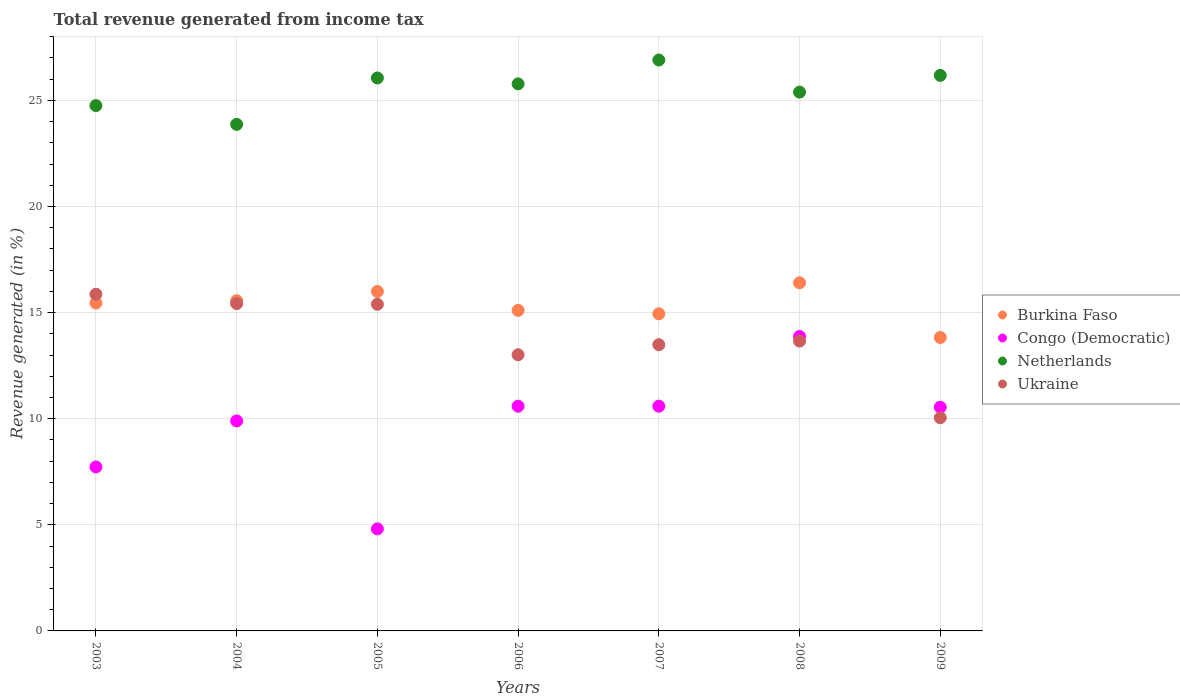How many different coloured dotlines are there?
Your answer should be compact. 4. What is the total revenue generated in Ukraine in 2004?
Give a very brief answer. 15.42. Across all years, what is the maximum total revenue generated in Burkina Faso?
Keep it short and to the point. 16.4. Across all years, what is the minimum total revenue generated in Netherlands?
Give a very brief answer. 23.87. In which year was the total revenue generated in Congo (Democratic) maximum?
Your answer should be compact. 2008. What is the total total revenue generated in Netherlands in the graph?
Keep it short and to the point. 178.93. What is the difference between the total revenue generated in Burkina Faso in 2004 and that in 2006?
Offer a terse response. 0.45. What is the difference between the total revenue generated in Burkina Faso in 2003 and the total revenue generated in Ukraine in 2009?
Provide a short and direct response. 5.4. What is the average total revenue generated in Ukraine per year?
Ensure brevity in your answer.  13.84. In the year 2004, what is the difference between the total revenue generated in Burkina Faso and total revenue generated in Congo (Democratic)?
Offer a very short reply. 5.66. In how many years, is the total revenue generated in Congo (Democratic) greater than 11 %?
Ensure brevity in your answer.  1. What is the ratio of the total revenue generated in Burkina Faso in 2003 to that in 2007?
Your response must be concise. 1.03. Is the total revenue generated in Congo (Democratic) in 2005 less than that in 2007?
Provide a short and direct response. Yes. What is the difference between the highest and the second highest total revenue generated in Netherlands?
Provide a succinct answer. 0.72. What is the difference between the highest and the lowest total revenue generated in Congo (Democratic)?
Provide a short and direct response. 9.07. In how many years, is the total revenue generated in Netherlands greater than the average total revenue generated in Netherlands taken over all years?
Give a very brief answer. 4. Is the sum of the total revenue generated in Netherlands in 2003 and 2009 greater than the maximum total revenue generated in Ukraine across all years?
Your answer should be compact. Yes. Is it the case that in every year, the sum of the total revenue generated in Congo (Democratic) and total revenue generated in Ukraine  is greater than the sum of total revenue generated in Netherlands and total revenue generated in Burkina Faso?
Your answer should be very brief. No. Is it the case that in every year, the sum of the total revenue generated in Ukraine and total revenue generated in Netherlands  is greater than the total revenue generated in Burkina Faso?
Ensure brevity in your answer.  Yes. Does the total revenue generated in Ukraine monotonically increase over the years?
Make the answer very short. No. Is the total revenue generated in Congo (Democratic) strictly greater than the total revenue generated in Ukraine over the years?
Your answer should be very brief. No. Does the graph contain any zero values?
Keep it short and to the point. No. What is the title of the graph?
Your response must be concise. Total revenue generated from income tax. Does "Rwanda" appear as one of the legend labels in the graph?
Offer a very short reply. No. What is the label or title of the X-axis?
Offer a terse response. Years. What is the label or title of the Y-axis?
Give a very brief answer. Revenue generated (in %). What is the Revenue generated (in %) in Burkina Faso in 2003?
Your answer should be compact. 15.45. What is the Revenue generated (in %) in Congo (Democratic) in 2003?
Your answer should be compact. 7.73. What is the Revenue generated (in %) in Netherlands in 2003?
Your answer should be very brief. 24.75. What is the Revenue generated (in %) in Ukraine in 2003?
Make the answer very short. 15.87. What is the Revenue generated (in %) of Burkina Faso in 2004?
Offer a terse response. 15.56. What is the Revenue generated (in %) of Congo (Democratic) in 2004?
Offer a very short reply. 9.9. What is the Revenue generated (in %) in Netherlands in 2004?
Provide a succinct answer. 23.87. What is the Revenue generated (in %) in Ukraine in 2004?
Offer a very short reply. 15.42. What is the Revenue generated (in %) in Burkina Faso in 2005?
Offer a terse response. 16. What is the Revenue generated (in %) in Congo (Democratic) in 2005?
Provide a short and direct response. 4.81. What is the Revenue generated (in %) in Netherlands in 2005?
Provide a short and direct response. 26.06. What is the Revenue generated (in %) in Ukraine in 2005?
Your response must be concise. 15.39. What is the Revenue generated (in %) in Burkina Faso in 2006?
Give a very brief answer. 15.11. What is the Revenue generated (in %) of Congo (Democratic) in 2006?
Your response must be concise. 10.59. What is the Revenue generated (in %) in Netherlands in 2006?
Ensure brevity in your answer.  25.78. What is the Revenue generated (in %) of Ukraine in 2006?
Your answer should be compact. 13.01. What is the Revenue generated (in %) in Burkina Faso in 2007?
Make the answer very short. 14.94. What is the Revenue generated (in %) of Congo (Democratic) in 2007?
Give a very brief answer. 10.59. What is the Revenue generated (in %) in Netherlands in 2007?
Your response must be concise. 26.9. What is the Revenue generated (in %) of Ukraine in 2007?
Your answer should be very brief. 13.49. What is the Revenue generated (in %) in Burkina Faso in 2008?
Ensure brevity in your answer.  16.4. What is the Revenue generated (in %) of Congo (Democratic) in 2008?
Offer a very short reply. 13.88. What is the Revenue generated (in %) of Netherlands in 2008?
Keep it short and to the point. 25.39. What is the Revenue generated (in %) of Ukraine in 2008?
Offer a terse response. 13.66. What is the Revenue generated (in %) in Burkina Faso in 2009?
Your answer should be very brief. 13.83. What is the Revenue generated (in %) of Congo (Democratic) in 2009?
Provide a succinct answer. 10.54. What is the Revenue generated (in %) of Netherlands in 2009?
Offer a terse response. 26.18. What is the Revenue generated (in %) of Ukraine in 2009?
Provide a short and direct response. 10.05. Across all years, what is the maximum Revenue generated (in %) of Burkina Faso?
Provide a short and direct response. 16.4. Across all years, what is the maximum Revenue generated (in %) in Congo (Democratic)?
Your answer should be compact. 13.88. Across all years, what is the maximum Revenue generated (in %) in Netherlands?
Ensure brevity in your answer.  26.9. Across all years, what is the maximum Revenue generated (in %) of Ukraine?
Offer a very short reply. 15.87. Across all years, what is the minimum Revenue generated (in %) in Burkina Faso?
Make the answer very short. 13.83. Across all years, what is the minimum Revenue generated (in %) in Congo (Democratic)?
Provide a succinct answer. 4.81. Across all years, what is the minimum Revenue generated (in %) of Netherlands?
Offer a terse response. 23.87. Across all years, what is the minimum Revenue generated (in %) in Ukraine?
Your answer should be very brief. 10.05. What is the total Revenue generated (in %) in Burkina Faso in the graph?
Provide a succinct answer. 107.28. What is the total Revenue generated (in %) in Congo (Democratic) in the graph?
Offer a terse response. 68.02. What is the total Revenue generated (in %) in Netherlands in the graph?
Give a very brief answer. 178.93. What is the total Revenue generated (in %) in Ukraine in the graph?
Provide a short and direct response. 96.89. What is the difference between the Revenue generated (in %) in Burkina Faso in 2003 and that in 2004?
Your response must be concise. -0.11. What is the difference between the Revenue generated (in %) in Congo (Democratic) in 2003 and that in 2004?
Your response must be concise. -2.17. What is the difference between the Revenue generated (in %) of Netherlands in 2003 and that in 2004?
Make the answer very short. 0.88. What is the difference between the Revenue generated (in %) of Ukraine in 2003 and that in 2004?
Make the answer very short. 0.44. What is the difference between the Revenue generated (in %) in Burkina Faso in 2003 and that in 2005?
Give a very brief answer. -0.55. What is the difference between the Revenue generated (in %) in Congo (Democratic) in 2003 and that in 2005?
Your answer should be very brief. 2.92. What is the difference between the Revenue generated (in %) of Netherlands in 2003 and that in 2005?
Ensure brevity in your answer.  -1.3. What is the difference between the Revenue generated (in %) in Ukraine in 2003 and that in 2005?
Provide a short and direct response. 0.47. What is the difference between the Revenue generated (in %) in Burkina Faso in 2003 and that in 2006?
Make the answer very short. 0.34. What is the difference between the Revenue generated (in %) of Congo (Democratic) in 2003 and that in 2006?
Your answer should be compact. -2.86. What is the difference between the Revenue generated (in %) in Netherlands in 2003 and that in 2006?
Keep it short and to the point. -1.02. What is the difference between the Revenue generated (in %) in Ukraine in 2003 and that in 2006?
Provide a succinct answer. 2.85. What is the difference between the Revenue generated (in %) of Burkina Faso in 2003 and that in 2007?
Keep it short and to the point. 0.51. What is the difference between the Revenue generated (in %) in Congo (Democratic) in 2003 and that in 2007?
Ensure brevity in your answer.  -2.86. What is the difference between the Revenue generated (in %) in Netherlands in 2003 and that in 2007?
Provide a short and direct response. -2.15. What is the difference between the Revenue generated (in %) in Ukraine in 2003 and that in 2007?
Provide a succinct answer. 2.38. What is the difference between the Revenue generated (in %) of Burkina Faso in 2003 and that in 2008?
Provide a succinct answer. -0.95. What is the difference between the Revenue generated (in %) in Congo (Democratic) in 2003 and that in 2008?
Your response must be concise. -6.15. What is the difference between the Revenue generated (in %) of Netherlands in 2003 and that in 2008?
Give a very brief answer. -0.63. What is the difference between the Revenue generated (in %) of Ukraine in 2003 and that in 2008?
Offer a very short reply. 2.21. What is the difference between the Revenue generated (in %) of Burkina Faso in 2003 and that in 2009?
Keep it short and to the point. 1.62. What is the difference between the Revenue generated (in %) in Congo (Democratic) in 2003 and that in 2009?
Your answer should be compact. -2.81. What is the difference between the Revenue generated (in %) of Netherlands in 2003 and that in 2009?
Your response must be concise. -1.42. What is the difference between the Revenue generated (in %) in Ukraine in 2003 and that in 2009?
Your answer should be compact. 5.82. What is the difference between the Revenue generated (in %) in Burkina Faso in 2004 and that in 2005?
Offer a very short reply. -0.44. What is the difference between the Revenue generated (in %) of Congo (Democratic) in 2004 and that in 2005?
Offer a very short reply. 5.09. What is the difference between the Revenue generated (in %) of Netherlands in 2004 and that in 2005?
Ensure brevity in your answer.  -2.19. What is the difference between the Revenue generated (in %) of Ukraine in 2004 and that in 2005?
Your answer should be very brief. 0.03. What is the difference between the Revenue generated (in %) in Burkina Faso in 2004 and that in 2006?
Make the answer very short. 0.45. What is the difference between the Revenue generated (in %) of Congo (Democratic) in 2004 and that in 2006?
Provide a short and direct response. -0.69. What is the difference between the Revenue generated (in %) of Netherlands in 2004 and that in 2006?
Offer a very short reply. -1.91. What is the difference between the Revenue generated (in %) of Ukraine in 2004 and that in 2006?
Your answer should be compact. 2.41. What is the difference between the Revenue generated (in %) of Burkina Faso in 2004 and that in 2007?
Keep it short and to the point. 0.62. What is the difference between the Revenue generated (in %) of Congo (Democratic) in 2004 and that in 2007?
Your answer should be very brief. -0.69. What is the difference between the Revenue generated (in %) of Netherlands in 2004 and that in 2007?
Your answer should be compact. -3.03. What is the difference between the Revenue generated (in %) in Ukraine in 2004 and that in 2007?
Offer a terse response. 1.94. What is the difference between the Revenue generated (in %) in Burkina Faso in 2004 and that in 2008?
Offer a very short reply. -0.85. What is the difference between the Revenue generated (in %) in Congo (Democratic) in 2004 and that in 2008?
Ensure brevity in your answer.  -3.98. What is the difference between the Revenue generated (in %) of Netherlands in 2004 and that in 2008?
Offer a very short reply. -1.52. What is the difference between the Revenue generated (in %) of Ukraine in 2004 and that in 2008?
Ensure brevity in your answer.  1.77. What is the difference between the Revenue generated (in %) in Burkina Faso in 2004 and that in 2009?
Your answer should be compact. 1.73. What is the difference between the Revenue generated (in %) in Congo (Democratic) in 2004 and that in 2009?
Offer a terse response. -0.64. What is the difference between the Revenue generated (in %) of Netherlands in 2004 and that in 2009?
Your response must be concise. -2.31. What is the difference between the Revenue generated (in %) in Ukraine in 2004 and that in 2009?
Provide a succinct answer. 5.38. What is the difference between the Revenue generated (in %) in Burkina Faso in 2005 and that in 2006?
Provide a short and direct response. 0.89. What is the difference between the Revenue generated (in %) of Congo (Democratic) in 2005 and that in 2006?
Your response must be concise. -5.78. What is the difference between the Revenue generated (in %) in Netherlands in 2005 and that in 2006?
Ensure brevity in your answer.  0.28. What is the difference between the Revenue generated (in %) of Ukraine in 2005 and that in 2006?
Offer a very short reply. 2.38. What is the difference between the Revenue generated (in %) in Burkina Faso in 2005 and that in 2007?
Your answer should be compact. 1.05. What is the difference between the Revenue generated (in %) of Congo (Democratic) in 2005 and that in 2007?
Offer a very short reply. -5.78. What is the difference between the Revenue generated (in %) in Netherlands in 2005 and that in 2007?
Your response must be concise. -0.85. What is the difference between the Revenue generated (in %) of Ukraine in 2005 and that in 2007?
Offer a very short reply. 1.9. What is the difference between the Revenue generated (in %) in Burkina Faso in 2005 and that in 2008?
Your answer should be compact. -0.41. What is the difference between the Revenue generated (in %) in Congo (Democratic) in 2005 and that in 2008?
Ensure brevity in your answer.  -9.07. What is the difference between the Revenue generated (in %) of Netherlands in 2005 and that in 2008?
Ensure brevity in your answer.  0.67. What is the difference between the Revenue generated (in %) in Ukraine in 2005 and that in 2008?
Keep it short and to the point. 1.73. What is the difference between the Revenue generated (in %) of Burkina Faso in 2005 and that in 2009?
Keep it short and to the point. 2.17. What is the difference between the Revenue generated (in %) of Congo (Democratic) in 2005 and that in 2009?
Your answer should be very brief. -5.73. What is the difference between the Revenue generated (in %) of Netherlands in 2005 and that in 2009?
Keep it short and to the point. -0.12. What is the difference between the Revenue generated (in %) of Ukraine in 2005 and that in 2009?
Make the answer very short. 5.35. What is the difference between the Revenue generated (in %) in Burkina Faso in 2006 and that in 2007?
Your response must be concise. 0.16. What is the difference between the Revenue generated (in %) in Congo (Democratic) in 2006 and that in 2007?
Your response must be concise. -0. What is the difference between the Revenue generated (in %) of Netherlands in 2006 and that in 2007?
Offer a very short reply. -1.12. What is the difference between the Revenue generated (in %) in Ukraine in 2006 and that in 2007?
Keep it short and to the point. -0.47. What is the difference between the Revenue generated (in %) of Burkina Faso in 2006 and that in 2008?
Your answer should be very brief. -1.3. What is the difference between the Revenue generated (in %) in Congo (Democratic) in 2006 and that in 2008?
Provide a short and direct response. -3.29. What is the difference between the Revenue generated (in %) of Netherlands in 2006 and that in 2008?
Provide a short and direct response. 0.39. What is the difference between the Revenue generated (in %) of Ukraine in 2006 and that in 2008?
Offer a very short reply. -0.64. What is the difference between the Revenue generated (in %) of Burkina Faso in 2006 and that in 2009?
Give a very brief answer. 1.28. What is the difference between the Revenue generated (in %) of Congo (Democratic) in 2006 and that in 2009?
Make the answer very short. 0.05. What is the difference between the Revenue generated (in %) of Ukraine in 2006 and that in 2009?
Ensure brevity in your answer.  2.97. What is the difference between the Revenue generated (in %) of Burkina Faso in 2007 and that in 2008?
Your answer should be compact. -1.46. What is the difference between the Revenue generated (in %) in Congo (Democratic) in 2007 and that in 2008?
Your answer should be compact. -3.28. What is the difference between the Revenue generated (in %) of Netherlands in 2007 and that in 2008?
Give a very brief answer. 1.51. What is the difference between the Revenue generated (in %) in Ukraine in 2007 and that in 2008?
Provide a short and direct response. -0.17. What is the difference between the Revenue generated (in %) in Burkina Faso in 2007 and that in 2009?
Offer a very short reply. 1.11. What is the difference between the Revenue generated (in %) of Congo (Democratic) in 2007 and that in 2009?
Keep it short and to the point. 0.05. What is the difference between the Revenue generated (in %) in Netherlands in 2007 and that in 2009?
Ensure brevity in your answer.  0.72. What is the difference between the Revenue generated (in %) in Ukraine in 2007 and that in 2009?
Offer a very short reply. 3.44. What is the difference between the Revenue generated (in %) of Burkina Faso in 2008 and that in 2009?
Make the answer very short. 2.58. What is the difference between the Revenue generated (in %) in Congo (Democratic) in 2008 and that in 2009?
Offer a terse response. 3.33. What is the difference between the Revenue generated (in %) in Netherlands in 2008 and that in 2009?
Your response must be concise. -0.79. What is the difference between the Revenue generated (in %) of Ukraine in 2008 and that in 2009?
Give a very brief answer. 3.61. What is the difference between the Revenue generated (in %) of Burkina Faso in 2003 and the Revenue generated (in %) of Congo (Democratic) in 2004?
Offer a very short reply. 5.55. What is the difference between the Revenue generated (in %) in Burkina Faso in 2003 and the Revenue generated (in %) in Netherlands in 2004?
Provide a short and direct response. -8.42. What is the difference between the Revenue generated (in %) of Burkina Faso in 2003 and the Revenue generated (in %) of Ukraine in 2004?
Provide a succinct answer. 0.02. What is the difference between the Revenue generated (in %) in Congo (Democratic) in 2003 and the Revenue generated (in %) in Netherlands in 2004?
Make the answer very short. -16.14. What is the difference between the Revenue generated (in %) of Congo (Democratic) in 2003 and the Revenue generated (in %) of Ukraine in 2004?
Your response must be concise. -7.7. What is the difference between the Revenue generated (in %) in Netherlands in 2003 and the Revenue generated (in %) in Ukraine in 2004?
Give a very brief answer. 9.33. What is the difference between the Revenue generated (in %) in Burkina Faso in 2003 and the Revenue generated (in %) in Congo (Democratic) in 2005?
Provide a succinct answer. 10.64. What is the difference between the Revenue generated (in %) in Burkina Faso in 2003 and the Revenue generated (in %) in Netherlands in 2005?
Offer a very short reply. -10.61. What is the difference between the Revenue generated (in %) of Burkina Faso in 2003 and the Revenue generated (in %) of Ukraine in 2005?
Make the answer very short. 0.06. What is the difference between the Revenue generated (in %) of Congo (Democratic) in 2003 and the Revenue generated (in %) of Netherlands in 2005?
Provide a succinct answer. -18.33. What is the difference between the Revenue generated (in %) in Congo (Democratic) in 2003 and the Revenue generated (in %) in Ukraine in 2005?
Give a very brief answer. -7.67. What is the difference between the Revenue generated (in %) of Netherlands in 2003 and the Revenue generated (in %) of Ukraine in 2005?
Offer a very short reply. 9.36. What is the difference between the Revenue generated (in %) in Burkina Faso in 2003 and the Revenue generated (in %) in Congo (Democratic) in 2006?
Offer a very short reply. 4.86. What is the difference between the Revenue generated (in %) in Burkina Faso in 2003 and the Revenue generated (in %) in Netherlands in 2006?
Give a very brief answer. -10.33. What is the difference between the Revenue generated (in %) of Burkina Faso in 2003 and the Revenue generated (in %) of Ukraine in 2006?
Offer a terse response. 2.44. What is the difference between the Revenue generated (in %) of Congo (Democratic) in 2003 and the Revenue generated (in %) of Netherlands in 2006?
Ensure brevity in your answer.  -18.05. What is the difference between the Revenue generated (in %) of Congo (Democratic) in 2003 and the Revenue generated (in %) of Ukraine in 2006?
Provide a short and direct response. -5.29. What is the difference between the Revenue generated (in %) of Netherlands in 2003 and the Revenue generated (in %) of Ukraine in 2006?
Keep it short and to the point. 11.74. What is the difference between the Revenue generated (in %) in Burkina Faso in 2003 and the Revenue generated (in %) in Congo (Democratic) in 2007?
Your response must be concise. 4.86. What is the difference between the Revenue generated (in %) in Burkina Faso in 2003 and the Revenue generated (in %) in Netherlands in 2007?
Provide a succinct answer. -11.45. What is the difference between the Revenue generated (in %) of Burkina Faso in 2003 and the Revenue generated (in %) of Ukraine in 2007?
Offer a very short reply. 1.96. What is the difference between the Revenue generated (in %) in Congo (Democratic) in 2003 and the Revenue generated (in %) in Netherlands in 2007?
Offer a very short reply. -19.17. What is the difference between the Revenue generated (in %) of Congo (Democratic) in 2003 and the Revenue generated (in %) of Ukraine in 2007?
Keep it short and to the point. -5.76. What is the difference between the Revenue generated (in %) of Netherlands in 2003 and the Revenue generated (in %) of Ukraine in 2007?
Give a very brief answer. 11.27. What is the difference between the Revenue generated (in %) in Burkina Faso in 2003 and the Revenue generated (in %) in Congo (Democratic) in 2008?
Offer a very short reply. 1.57. What is the difference between the Revenue generated (in %) of Burkina Faso in 2003 and the Revenue generated (in %) of Netherlands in 2008?
Keep it short and to the point. -9.94. What is the difference between the Revenue generated (in %) of Burkina Faso in 2003 and the Revenue generated (in %) of Ukraine in 2008?
Give a very brief answer. 1.79. What is the difference between the Revenue generated (in %) in Congo (Democratic) in 2003 and the Revenue generated (in %) in Netherlands in 2008?
Provide a succinct answer. -17.66. What is the difference between the Revenue generated (in %) of Congo (Democratic) in 2003 and the Revenue generated (in %) of Ukraine in 2008?
Ensure brevity in your answer.  -5.93. What is the difference between the Revenue generated (in %) of Netherlands in 2003 and the Revenue generated (in %) of Ukraine in 2008?
Your answer should be compact. 11.1. What is the difference between the Revenue generated (in %) in Burkina Faso in 2003 and the Revenue generated (in %) in Congo (Democratic) in 2009?
Your response must be concise. 4.91. What is the difference between the Revenue generated (in %) in Burkina Faso in 2003 and the Revenue generated (in %) in Netherlands in 2009?
Provide a short and direct response. -10.73. What is the difference between the Revenue generated (in %) in Burkina Faso in 2003 and the Revenue generated (in %) in Ukraine in 2009?
Offer a terse response. 5.4. What is the difference between the Revenue generated (in %) of Congo (Democratic) in 2003 and the Revenue generated (in %) of Netherlands in 2009?
Your response must be concise. -18.45. What is the difference between the Revenue generated (in %) in Congo (Democratic) in 2003 and the Revenue generated (in %) in Ukraine in 2009?
Offer a very short reply. -2.32. What is the difference between the Revenue generated (in %) in Netherlands in 2003 and the Revenue generated (in %) in Ukraine in 2009?
Give a very brief answer. 14.71. What is the difference between the Revenue generated (in %) of Burkina Faso in 2004 and the Revenue generated (in %) of Congo (Democratic) in 2005?
Provide a succinct answer. 10.75. What is the difference between the Revenue generated (in %) in Burkina Faso in 2004 and the Revenue generated (in %) in Netherlands in 2005?
Your answer should be very brief. -10.5. What is the difference between the Revenue generated (in %) in Burkina Faso in 2004 and the Revenue generated (in %) in Ukraine in 2005?
Offer a very short reply. 0.17. What is the difference between the Revenue generated (in %) of Congo (Democratic) in 2004 and the Revenue generated (in %) of Netherlands in 2005?
Provide a short and direct response. -16.16. What is the difference between the Revenue generated (in %) of Congo (Democratic) in 2004 and the Revenue generated (in %) of Ukraine in 2005?
Your answer should be compact. -5.5. What is the difference between the Revenue generated (in %) of Netherlands in 2004 and the Revenue generated (in %) of Ukraine in 2005?
Keep it short and to the point. 8.48. What is the difference between the Revenue generated (in %) of Burkina Faso in 2004 and the Revenue generated (in %) of Congo (Democratic) in 2006?
Ensure brevity in your answer.  4.97. What is the difference between the Revenue generated (in %) in Burkina Faso in 2004 and the Revenue generated (in %) in Netherlands in 2006?
Provide a succinct answer. -10.22. What is the difference between the Revenue generated (in %) in Burkina Faso in 2004 and the Revenue generated (in %) in Ukraine in 2006?
Keep it short and to the point. 2.55. What is the difference between the Revenue generated (in %) of Congo (Democratic) in 2004 and the Revenue generated (in %) of Netherlands in 2006?
Your answer should be very brief. -15.88. What is the difference between the Revenue generated (in %) of Congo (Democratic) in 2004 and the Revenue generated (in %) of Ukraine in 2006?
Keep it short and to the point. -3.12. What is the difference between the Revenue generated (in %) of Netherlands in 2004 and the Revenue generated (in %) of Ukraine in 2006?
Your answer should be compact. 10.86. What is the difference between the Revenue generated (in %) of Burkina Faso in 2004 and the Revenue generated (in %) of Congo (Democratic) in 2007?
Provide a succinct answer. 4.97. What is the difference between the Revenue generated (in %) in Burkina Faso in 2004 and the Revenue generated (in %) in Netherlands in 2007?
Give a very brief answer. -11.34. What is the difference between the Revenue generated (in %) of Burkina Faso in 2004 and the Revenue generated (in %) of Ukraine in 2007?
Make the answer very short. 2.07. What is the difference between the Revenue generated (in %) in Congo (Democratic) in 2004 and the Revenue generated (in %) in Netherlands in 2007?
Your response must be concise. -17.01. What is the difference between the Revenue generated (in %) of Congo (Democratic) in 2004 and the Revenue generated (in %) of Ukraine in 2007?
Your answer should be very brief. -3.59. What is the difference between the Revenue generated (in %) of Netherlands in 2004 and the Revenue generated (in %) of Ukraine in 2007?
Offer a very short reply. 10.38. What is the difference between the Revenue generated (in %) in Burkina Faso in 2004 and the Revenue generated (in %) in Congo (Democratic) in 2008?
Give a very brief answer. 1.68. What is the difference between the Revenue generated (in %) of Burkina Faso in 2004 and the Revenue generated (in %) of Netherlands in 2008?
Your answer should be compact. -9.83. What is the difference between the Revenue generated (in %) of Burkina Faso in 2004 and the Revenue generated (in %) of Ukraine in 2008?
Ensure brevity in your answer.  1.9. What is the difference between the Revenue generated (in %) in Congo (Democratic) in 2004 and the Revenue generated (in %) in Netherlands in 2008?
Your response must be concise. -15.49. What is the difference between the Revenue generated (in %) of Congo (Democratic) in 2004 and the Revenue generated (in %) of Ukraine in 2008?
Provide a short and direct response. -3.76. What is the difference between the Revenue generated (in %) of Netherlands in 2004 and the Revenue generated (in %) of Ukraine in 2008?
Offer a terse response. 10.21. What is the difference between the Revenue generated (in %) in Burkina Faso in 2004 and the Revenue generated (in %) in Congo (Democratic) in 2009?
Provide a short and direct response. 5.02. What is the difference between the Revenue generated (in %) of Burkina Faso in 2004 and the Revenue generated (in %) of Netherlands in 2009?
Provide a succinct answer. -10.62. What is the difference between the Revenue generated (in %) of Burkina Faso in 2004 and the Revenue generated (in %) of Ukraine in 2009?
Keep it short and to the point. 5.51. What is the difference between the Revenue generated (in %) of Congo (Democratic) in 2004 and the Revenue generated (in %) of Netherlands in 2009?
Offer a terse response. -16.28. What is the difference between the Revenue generated (in %) in Congo (Democratic) in 2004 and the Revenue generated (in %) in Ukraine in 2009?
Your response must be concise. -0.15. What is the difference between the Revenue generated (in %) of Netherlands in 2004 and the Revenue generated (in %) of Ukraine in 2009?
Offer a very short reply. 13.82. What is the difference between the Revenue generated (in %) in Burkina Faso in 2005 and the Revenue generated (in %) in Congo (Democratic) in 2006?
Offer a very short reply. 5.41. What is the difference between the Revenue generated (in %) of Burkina Faso in 2005 and the Revenue generated (in %) of Netherlands in 2006?
Make the answer very short. -9.78. What is the difference between the Revenue generated (in %) of Burkina Faso in 2005 and the Revenue generated (in %) of Ukraine in 2006?
Ensure brevity in your answer.  2.98. What is the difference between the Revenue generated (in %) of Congo (Democratic) in 2005 and the Revenue generated (in %) of Netherlands in 2006?
Your answer should be very brief. -20.97. What is the difference between the Revenue generated (in %) in Congo (Democratic) in 2005 and the Revenue generated (in %) in Ukraine in 2006?
Your response must be concise. -8.21. What is the difference between the Revenue generated (in %) in Netherlands in 2005 and the Revenue generated (in %) in Ukraine in 2006?
Provide a succinct answer. 13.04. What is the difference between the Revenue generated (in %) in Burkina Faso in 2005 and the Revenue generated (in %) in Congo (Democratic) in 2007?
Provide a short and direct response. 5.41. What is the difference between the Revenue generated (in %) of Burkina Faso in 2005 and the Revenue generated (in %) of Netherlands in 2007?
Provide a short and direct response. -10.91. What is the difference between the Revenue generated (in %) in Burkina Faso in 2005 and the Revenue generated (in %) in Ukraine in 2007?
Ensure brevity in your answer.  2.51. What is the difference between the Revenue generated (in %) in Congo (Democratic) in 2005 and the Revenue generated (in %) in Netherlands in 2007?
Provide a short and direct response. -22.09. What is the difference between the Revenue generated (in %) of Congo (Democratic) in 2005 and the Revenue generated (in %) of Ukraine in 2007?
Give a very brief answer. -8.68. What is the difference between the Revenue generated (in %) in Netherlands in 2005 and the Revenue generated (in %) in Ukraine in 2007?
Your answer should be very brief. 12.57. What is the difference between the Revenue generated (in %) in Burkina Faso in 2005 and the Revenue generated (in %) in Congo (Democratic) in 2008?
Keep it short and to the point. 2.12. What is the difference between the Revenue generated (in %) in Burkina Faso in 2005 and the Revenue generated (in %) in Netherlands in 2008?
Your answer should be very brief. -9.39. What is the difference between the Revenue generated (in %) of Burkina Faso in 2005 and the Revenue generated (in %) of Ukraine in 2008?
Provide a succinct answer. 2.34. What is the difference between the Revenue generated (in %) in Congo (Democratic) in 2005 and the Revenue generated (in %) in Netherlands in 2008?
Your answer should be compact. -20.58. What is the difference between the Revenue generated (in %) of Congo (Democratic) in 2005 and the Revenue generated (in %) of Ukraine in 2008?
Provide a short and direct response. -8.85. What is the difference between the Revenue generated (in %) in Netherlands in 2005 and the Revenue generated (in %) in Ukraine in 2008?
Your answer should be compact. 12.4. What is the difference between the Revenue generated (in %) in Burkina Faso in 2005 and the Revenue generated (in %) in Congo (Democratic) in 2009?
Provide a short and direct response. 5.45. What is the difference between the Revenue generated (in %) of Burkina Faso in 2005 and the Revenue generated (in %) of Netherlands in 2009?
Your answer should be compact. -10.18. What is the difference between the Revenue generated (in %) in Burkina Faso in 2005 and the Revenue generated (in %) in Ukraine in 2009?
Your answer should be compact. 5.95. What is the difference between the Revenue generated (in %) in Congo (Democratic) in 2005 and the Revenue generated (in %) in Netherlands in 2009?
Offer a terse response. -21.37. What is the difference between the Revenue generated (in %) in Congo (Democratic) in 2005 and the Revenue generated (in %) in Ukraine in 2009?
Keep it short and to the point. -5.24. What is the difference between the Revenue generated (in %) in Netherlands in 2005 and the Revenue generated (in %) in Ukraine in 2009?
Your answer should be compact. 16.01. What is the difference between the Revenue generated (in %) in Burkina Faso in 2006 and the Revenue generated (in %) in Congo (Democratic) in 2007?
Keep it short and to the point. 4.51. What is the difference between the Revenue generated (in %) in Burkina Faso in 2006 and the Revenue generated (in %) in Netherlands in 2007?
Your response must be concise. -11.8. What is the difference between the Revenue generated (in %) of Burkina Faso in 2006 and the Revenue generated (in %) of Ukraine in 2007?
Your answer should be very brief. 1.62. What is the difference between the Revenue generated (in %) of Congo (Democratic) in 2006 and the Revenue generated (in %) of Netherlands in 2007?
Keep it short and to the point. -16.31. What is the difference between the Revenue generated (in %) in Congo (Democratic) in 2006 and the Revenue generated (in %) in Ukraine in 2007?
Ensure brevity in your answer.  -2.9. What is the difference between the Revenue generated (in %) of Netherlands in 2006 and the Revenue generated (in %) of Ukraine in 2007?
Offer a terse response. 12.29. What is the difference between the Revenue generated (in %) of Burkina Faso in 2006 and the Revenue generated (in %) of Congo (Democratic) in 2008?
Offer a terse response. 1.23. What is the difference between the Revenue generated (in %) in Burkina Faso in 2006 and the Revenue generated (in %) in Netherlands in 2008?
Ensure brevity in your answer.  -10.28. What is the difference between the Revenue generated (in %) of Burkina Faso in 2006 and the Revenue generated (in %) of Ukraine in 2008?
Offer a very short reply. 1.45. What is the difference between the Revenue generated (in %) of Congo (Democratic) in 2006 and the Revenue generated (in %) of Netherlands in 2008?
Offer a very short reply. -14.8. What is the difference between the Revenue generated (in %) of Congo (Democratic) in 2006 and the Revenue generated (in %) of Ukraine in 2008?
Your answer should be compact. -3.07. What is the difference between the Revenue generated (in %) of Netherlands in 2006 and the Revenue generated (in %) of Ukraine in 2008?
Your response must be concise. 12.12. What is the difference between the Revenue generated (in %) of Burkina Faso in 2006 and the Revenue generated (in %) of Congo (Democratic) in 2009?
Provide a short and direct response. 4.56. What is the difference between the Revenue generated (in %) in Burkina Faso in 2006 and the Revenue generated (in %) in Netherlands in 2009?
Your answer should be compact. -11.07. What is the difference between the Revenue generated (in %) in Burkina Faso in 2006 and the Revenue generated (in %) in Ukraine in 2009?
Provide a short and direct response. 5.06. What is the difference between the Revenue generated (in %) in Congo (Democratic) in 2006 and the Revenue generated (in %) in Netherlands in 2009?
Your answer should be very brief. -15.59. What is the difference between the Revenue generated (in %) in Congo (Democratic) in 2006 and the Revenue generated (in %) in Ukraine in 2009?
Offer a terse response. 0.54. What is the difference between the Revenue generated (in %) of Netherlands in 2006 and the Revenue generated (in %) of Ukraine in 2009?
Ensure brevity in your answer.  15.73. What is the difference between the Revenue generated (in %) of Burkina Faso in 2007 and the Revenue generated (in %) of Congo (Democratic) in 2008?
Offer a terse response. 1.07. What is the difference between the Revenue generated (in %) in Burkina Faso in 2007 and the Revenue generated (in %) in Netherlands in 2008?
Give a very brief answer. -10.45. What is the difference between the Revenue generated (in %) in Burkina Faso in 2007 and the Revenue generated (in %) in Ukraine in 2008?
Your response must be concise. 1.29. What is the difference between the Revenue generated (in %) of Congo (Democratic) in 2007 and the Revenue generated (in %) of Netherlands in 2008?
Provide a short and direct response. -14.8. What is the difference between the Revenue generated (in %) of Congo (Democratic) in 2007 and the Revenue generated (in %) of Ukraine in 2008?
Offer a terse response. -3.07. What is the difference between the Revenue generated (in %) in Netherlands in 2007 and the Revenue generated (in %) in Ukraine in 2008?
Keep it short and to the point. 13.24. What is the difference between the Revenue generated (in %) of Burkina Faso in 2007 and the Revenue generated (in %) of Congo (Democratic) in 2009?
Your response must be concise. 4.4. What is the difference between the Revenue generated (in %) in Burkina Faso in 2007 and the Revenue generated (in %) in Netherlands in 2009?
Your answer should be compact. -11.23. What is the difference between the Revenue generated (in %) of Burkina Faso in 2007 and the Revenue generated (in %) of Ukraine in 2009?
Offer a terse response. 4.9. What is the difference between the Revenue generated (in %) in Congo (Democratic) in 2007 and the Revenue generated (in %) in Netherlands in 2009?
Offer a very short reply. -15.59. What is the difference between the Revenue generated (in %) in Congo (Democratic) in 2007 and the Revenue generated (in %) in Ukraine in 2009?
Make the answer very short. 0.55. What is the difference between the Revenue generated (in %) in Netherlands in 2007 and the Revenue generated (in %) in Ukraine in 2009?
Offer a terse response. 16.86. What is the difference between the Revenue generated (in %) in Burkina Faso in 2008 and the Revenue generated (in %) in Congo (Democratic) in 2009?
Your answer should be very brief. 5.86. What is the difference between the Revenue generated (in %) in Burkina Faso in 2008 and the Revenue generated (in %) in Netherlands in 2009?
Keep it short and to the point. -9.77. What is the difference between the Revenue generated (in %) in Burkina Faso in 2008 and the Revenue generated (in %) in Ukraine in 2009?
Give a very brief answer. 6.36. What is the difference between the Revenue generated (in %) in Congo (Democratic) in 2008 and the Revenue generated (in %) in Netherlands in 2009?
Provide a short and direct response. -12.3. What is the difference between the Revenue generated (in %) in Congo (Democratic) in 2008 and the Revenue generated (in %) in Ukraine in 2009?
Ensure brevity in your answer.  3.83. What is the difference between the Revenue generated (in %) of Netherlands in 2008 and the Revenue generated (in %) of Ukraine in 2009?
Keep it short and to the point. 15.34. What is the average Revenue generated (in %) of Burkina Faso per year?
Make the answer very short. 15.33. What is the average Revenue generated (in %) in Congo (Democratic) per year?
Keep it short and to the point. 9.72. What is the average Revenue generated (in %) in Netherlands per year?
Provide a succinct answer. 25.56. What is the average Revenue generated (in %) of Ukraine per year?
Make the answer very short. 13.84. In the year 2003, what is the difference between the Revenue generated (in %) in Burkina Faso and Revenue generated (in %) in Congo (Democratic)?
Provide a succinct answer. 7.72. In the year 2003, what is the difference between the Revenue generated (in %) in Burkina Faso and Revenue generated (in %) in Netherlands?
Provide a short and direct response. -9.3. In the year 2003, what is the difference between the Revenue generated (in %) in Burkina Faso and Revenue generated (in %) in Ukraine?
Your response must be concise. -0.42. In the year 2003, what is the difference between the Revenue generated (in %) in Congo (Democratic) and Revenue generated (in %) in Netherlands?
Keep it short and to the point. -17.03. In the year 2003, what is the difference between the Revenue generated (in %) of Congo (Democratic) and Revenue generated (in %) of Ukraine?
Provide a short and direct response. -8.14. In the year 2003, what is the difference between the Revenue generated (in %) of Netherlands and Revenue generated (in %) of Ukraine?
Provide a short and direct response. 8.89. In the year 2004, what is the difference between the Revenue generated (in %) of Burkina Faso and Revenue generated (in %) of Congo (Democratic)?
Offer a very short reply. 5.66. In the year 2004, what is the difference between the Revenue generated (in %) of Burkina Faso and Revenue generated (in %) of Netherlands?
Offer a terse response. -8.31. In the year 2004, what is the difference between the Revenue generated (in %) of Burkina Faso and Revenue generated (in %) of Ukraine?
Provide a succinct answer. 0.13. In the year 2004, what is the difference between the Revenue generated (in %) in Congo (Democratic) and Revenue generated (in %) in Netherlands?
Your answer should be compact. -13.97. In the year 2004, what is the difference between the Revenue generated (in %) of Congo (Democratic) and Revenue generated (in %) of Ukraine?
Provide a succinct answer. -5.53. In the year 2004, what is the difference between the Revenue generated (in %) in Netherlands and Revenue generated (in %) in Ukraine?
Keep it short and to the point. 8.44. In the year 2005, what is the difference between the Revenue generated (in %) of Burkina Faso and Revenue generated (in %) of Congo (Democratic)?
Ensure brevity in your answer.  11.19. In the year 2005, what is the difference between the Revenue generated (in %) of Burkina Faso and Revenue generated (in %) of Netherlands?
Provide a succinct answer. -10.06. In the year 2005, what is the difference between the Revenue generated (in %) in Burkina Faso and Revenue generated (in %) in Ukraine?
Offer a terse response. 0.6. In the year 2005, what is the difference between the Revenue generated (in %) in Congo (Democratic) and Revenue generated (in %) in Netherlands?
Offer a terse response. -21.25. In the year 2005, what is the difference between the Revenue generated (in %) of Congo (Democratic) and Revenue generated (in %) of Ukraine?
Provide a succinct answer. -10.58. In the year 2005, what is the difference between the Revenue generated (in %) in Netherlands and Revenue generated (in %) in Ukraine?
Provide a succinct answer. 10.66. In the year 2006, what is the difference between the Revenue generated (in %) of Burkina Faso and Revenue generated (in %) of Congo (Democratic)?
Your answer should be very brief. 4.52. In the year 2006, what is the difference between the Revenue generated (in %) of Burkina Faso and Revenue generated (in %) of Netherlands?
Ensure brevity in your answer.  -10.67. In the year 2006, what is the difference between the Revenue generated (in %) of Burkina Faso and Revenue generated (in %) of Ukraine?
Ensure brevity in your answer.  2.09. In the year 2006, what is the difference between the Revenue generated (in %) of Congo (Democratic) and Revenue generated (in %) of Netherlands?
Provide a succinct answer. -15.19. In the year 2006, what is the difference between the Revenue generated (in %) of Congo (Democratic) and Revenue generated (in %) of Ukraine?
Provide a succinct answer. -2.42. In the year 2006, what is the difference between the Revenue generated (in %) in Netherlands and Revenue generated (in %) in Ukraine?
Give a very brief answer. 12.76. In the year 2007, what is the difference between the Revenue generated (in %) of Burkina Faso and Revenue generated (in %) of Congo (Democratic)?
Your answer should be very brief. 4.35. In the year 2007, what is the difference between the Revenue generated (in %) in Burkina Faso and Revenue generated (in %) in Netherlands?
Your response must be concise. -11.96. In the year 2007, what is the difference between the Revenue generated (in %) in Burkina Faso and Revenue generated (in %) in Ukraine?
Your response must be concise. 1.46. In the year 2007, what is the difference between the Revenue generated (in %) in Congo (Democratic) and Revenue generated (in %) in Netherlands?
Your response must be concise. -16.31. In the year 2007, what is the difference between the Revenue generated (in %) of Congo (Democratic) and Revenue generated (in %) of Ukraine?
Provide a short and direct response. -2.9. In the year 2007, what is the difference between the Revenue generated (in %) of Netherlands and Revenue generated (in %) of Ukraine?
Offer a terse response. 13.41. In the year 2008, what is the difference between the Revenue generated (in %) in Burkina Faso and Revenue generated (in %) in Congo (Democratic)?
Your answer should be very brief. 2.53. In the year 2008, what is the difference between the Revenue generated (in %) in Burkina Faso and Revenue generated (in %) in Netherlands?
Your answer should be very brief. -8.98. In the year 2008, what is the difference between the Revenue generated (in %) in Burkina Faso and Revenue generated (in %) in Ukraine?
Give a very brief answer. 2.75. In the year 2008, what is the difference between the Revenue generated (in %) of Congo (Democratic) and Revenue generated (in %) of Netherlands?
Keep it short and to the point. -11.51. In the year 2008, what is the difference between the Revenue generated (in %) in Congo (Democratic) and Revenue generated (in %) in Ukraine?
Offer a terse response. 0.22. In the year 2008, what is the difference between the Revenue generated (in %) of Netherlands and Revenue generated (in %) of Ukraine?
Your response must be concise. 11.73. In the year 2009, what is the difference between the Revenue generated (in %) of Burkina Faso and Revenue generated (in %) of Congo (Democratic)?
Ensure brevity in your answer.  3.29. In the year 2009, what is the difference between the Revenue generated (in %) in Burkina Faso and Revenue generated (in %) in Netherlands?
Offer a terse response. -12.35. In the year 2009, what is the difference between the Revenue generated (in %) in Burkina Faso and Revenue generated (in %) in Ukraine?
Offer a very short reply. 3.78. In the year 2009, what is the difference between the Revenue generated (in %) in Congo (Democratic) and Revenue generated (in %) in Netherlands?
Offer a terse response. -15.64. In the year 2009, what is the difference between the Revenue generated (in %) of Congo (Democratic) and Revenue generated (in %) of Ukraine?
Your answer should be very brief. 0.5. In the year 2009, what is the difference between the Revenue generated (in %) in Netherlands and Revenue generated (in %) in Ukraine?
Your answer should be compact. 16.13. What is the ratio of the Revenue generated (in %) in Congo (Democratic) in 2003 to that in 2004?
Offer a very short reply. 0.78. What is the ratio of the Revenue generated (in %) in Netherlands in 2003 to that in 2004?
Your response must be concise. 1.04. What is the ratio of the Revenue generated (in %) in Ukraine in 2003 to that in 2004?
Your response must be concise. 1.03. What is the ratio of the Revenue generated (in %) in Burkina Faso in 2003 to that in 2005?
Your answer should be very brief. 0.97. What is the ratio of the Revenue generated (in %) of Congo (Democratic) in 2003 to that in 2005?
Ensure brevity in your answer.  1.61. What is the ratio of the Revenue generated (in %) in Netherlands in 2003 to that in 2005?
Give a very brief answer. 0.95. What is the ratio of the Revenue generated (in %) in Ukraine in 2003 to that in 2005?
Offer a very short reply. 1.03. What is the ratio of the Revenue generated (in %) of Burkina Faso in 2003 to that in 2006?
Your answer should be very brief. 1.02. What is the ratio of the Revenue generated (in %) of Congo (Democratic) in 2003 to that in 2006?
Your answer should be very brief. 0.73. What is the ratio of the Revenue generated (in %) in Netherlands in 2003 to that in 2006?
Provide a short and direct response. 0.96. What is the ratio of the Revenue generated (in %) in Ukraine in 2003 to that in 2006?
Ensure brevity in your answer.  1.22. What is the ratio of the Revenue generated (in %) in Burkina Faso in 2003 to that in 2007?
Make the answer very short. 1.03. What is the ratio of the Revenue generated (in %) of Congo (Democratic) in 2003 to that in 2007?
Give a very brief answer. 0.73. What is the ratio of the Revenue generated (in %) of Netherlands in 2003 to that in 2007?
Offer a terse response. 0.92. What is the ratio of the Revenue generated (in %) in Ukraine in 2003 to that in 2007?
Keep it short and to the point. 1.18. What is the ratio of the Revenue generated (in %) in Burkina Faso in 2003 to that in 2008?
Your answer should be compact. 0.94. What is the ratio of the Revenue generated (in %) of Congo (Democratic) in 2003 to that in 2008?
Give a very brief answer. 0.56. What is the ratio of the Revenue generated (in %) in Ukraine in 2003 to that in 2008?
Keep it short and to the point. 1.16. What is the ratio of the Revenue generated (in %) in Burkina Faso in 2003 to that in 2009?
Your answer should be very brief. 1.12. What is the ratio of the Revenue generated (in %) in Congo (Democratic) in 2003 to that in 2009?
Offer a terse response. 0.73. What is the ratio of the Revenue generated (in %) of Netherlands in 2003 to that in 2009?
Give a very brief answer. 0.95. What is the ratio of the Revenue generated (in %) of Ukraine in 2003 to that in 2009?
Your answer should be compact. 1.58. What is the ratio of the Revenue generated (in %) in Burkina Faso in 2004 to that in 2005?
Provide a succinct answer. 0.97. What is the ratio of the Revenue generated (in %) of Congo (Democratic) in 2004 to that in 2005?
Make the answer very short. 2.06. What is the ratio of the Revenue generated (in %) of Netherlands in 2004 to that in 2005?
Keep it short and to the point. 0.92. What is the ratio of the Revenue generated (in %) of Burkina Faso in 2004 to that in 2006?
Make the answer very short. 1.03. What is the ratio of the Revenue generated (in %) in Congo (Democratic) in 2004 to that in 2006?
Make the answer very short. 0.93. What is the ratio of the Revenue generated (in %) in Netherlands in 2004 to that in 2006?
Your response must be concise. 0.93. What is the ratio of the Revenue generated (in %) in Ukraine in 2004 to that in 2006?
Offer a very short reply. 1.19. What is the ratio of the Revenue generated (in %) in Burkina Faso in 2004 to that in 2007?
Your response must be concise. 1.04. What is the ratio of the Revenue generated (in %) of Congo (Democratic) in 2004 to that in 2007?
Offer a very short reply. 0.93. What is the ratio of the Revenue generated (in %) in Netherlands in 2004 to that in 2007?
Your response must be concise. 0.89. What is the ratio of the Revenue generated (in %) in Ukraine in 2004 to that in 2007?
Provide a succinct answer. 1.14. What is the ratio of the Revenue generated (in %) of Burkina Faso in 2004 to that in 2008?
Offer a very short reply. 0.95. What is the ratio of the Revenue generated (in %) in Congo (Democratic) in 2004 to that in 2008?
Give a very brief answer. 0.71. What is the ratio of the Revenue generated (in %) of Netherlands in 2004 to that in 2008?
Your answer should be compact. 0.94. What is the ratio of the Revenue generated (in %) of Ukraine in 2004 to that in 2008?
Keep it short and to the point. 1.13. What is the ratio of the Revenue generated (in %) of Burkina Faso in 2004 to that in 2009?
Make the answer very short. 1.13. What is the ratio of the Revenue generated (in %) of Congo (Democratic) in 2004 to that in 2009?
Make the answer very short. 0.94. What is the ratio of the Revenue generated (in %) of Netherlands in 2004 to that in 2009?
Give a very brief answer. 0.91. What is the ratio of the Revenue generated (in %) of Ukraine in 2004 to that in 2009?
Keep it short and to the point. 1.54. What is the ratio of the Revenue generated (in %) in Burkina Faso in 2005 to that in 2006?
Give a very brief answer. 1.06. What is the ratio of the Revenue generated (in %) in Congo (Democratic) in 2005 to that in 2006?
Offer a terse response. 0.45. What is the ratio of the Revenue generated (in %) in Netherlands in 2005 to that in 2006?
Offer a terse response. 1.01. What is the ratio of the Revenue generated (in %) in Ukraine in 2005 to that in 2006?
Your response must be concise. 1.18. What is the ratio of the Revenue generated (in %) in Burkina Faso in 2005 to that in 2007?
Give a very brief answer. 1.07. What is the ratio of the Revenue generated (in %) of Congo (Democratic) in 2005 to that in 2007?
Give a very brief answer. 0.45. What is the ratio of the Revenue generated (in %) in Netherlands in 2005 to that in 2007?
Make the answer very short. 0.97. What is the ratio of the Revenue generated (in %) in Ukraine in 2005 to that in 2007?
Ensure brevity in your answer.  1.14. What is the ratio of the Revenue generated (in %) of Burkina Faso in 2005 to that in 2008?
Provide a short and direct response. 0.98. What is the ratio of the Revenue generated (in %) of Congo (Democratic) in 2005 to that in 2008?
Your response must be concise. 0.35. What is the ratio of the Revenue generated (in %) of Netherlands in 2005 to that in 2008?
Offer a terse response. 1.03. What is the ratio of the Revenue generated (in %) in Ukraine in 2005 to that in 2008?
Keep it short and to the point. 1.13. What is the ratio of the Revenue generated (in %) in Burkina Faso in 2005 to that in 2009?
Give a very brief answer. 1.16. What is the ratio of the Revenue generated (in %) of Congo (Democratic) in 2005 to that in 2009?
Ensure brevity in your answer.  0.46. What is the ratio of the Revenue generated (in %) of Ukraine in 2005 to that in 2009?
Provide a succinct answer. 1.53. What is the ratio of the Revenue generated (in %) in Burkina Faso in 2006 to that in 2007?
Your answer should be very brief. 1.01. What is the ratio of the Revenue generated (in %) of Congo (Democratic) in 2006 to that in 2007?
Your answer should be compact. 1. What is the ratio of the Revenue generated (in %) in Netherlands in 2006 to that in 2007?
Your response must be concise. 0.96. What is the ratio of the Revenue generated (in %) of Ukraine in 2006 to that in 2007?
Offer a very short reply. 0.96. What is the ratio of the Revenue generated (in %) in Burkina Faso in 2006 to that in 2008?
Keep it short and to the point. 0.92. What is the ratio of the Revenue generated (in %) of Congo (Democratic) in 2006 to that in 2008?
Offer a very short reply. 0.76. What is the ratio of the Revenue generated (in %) of Netherlands in 2006 to that in 2008?
Your answer should be compact. 1.02. What is the ratio of the Revenue generated (in %) in Ukraine in 2006 to that in 2008?
Your response must be concise. 0.95. What is the ratio of the Revenue generated (in %) in Burkina Faso in 2006 to that in 2009?
Provide a succinct answer. 1.09. What is the ratio of the Revenue generated (in %) of Netherlands in 2006 to that in 2009?
Your answer should be very brief. 0.98. What is the ratio of the Revenue generated (in %) of Ukraine in 2006 to that in 2009?
Give a very brief answer. 1.3. What is the ratio of the Revenue generated (in %) in Burkina Faso in 2007 to that in 2008?
Provide a short and direct response. 0.91. What is the ratio of the Revenue generated (in %) of Congo (Democratic) in 2007 to that in 2008?
Make the answer very short. 0.76. What is the ratio of the Revenue generated (in %) of Netherlands in 2007 to that in 2008?
Give a very brief answer. 1.06. What is the ratio of the Revenue generated (in %) in Ukraine in 2007 to that in 2008?
Offer a terse response. 0.99. What is the ratio of the Revenue generated (in %) of Burkina Faso in 2007 to that in 2009?
Give a very brief answer. 1.08. What is the ratio of the Revenue generated (in %) of Netherlands in 2007 to that in 2009?
Offer a very short reply. 1.03. What is the ratio of the Revenue generated (in %) in Ukraine in 2007 to that in 2009?
Give a very brief answer. 1.34. What is the ratio of the Revenue generated (in %) of Burkina Faso in 2008 to that in 2009?
Make the answer very short. 1.19. What is the ratio of the Revenue generated (in %) in Congo (Democratic) in 2008 to that in 2009?
Provide a succinct answer. 1.32. What is the ratio of the Revenue generated (in %) in Netherlands in 2008 to that in 2009?
Offer a terse response. 0.97. What is the ratio of the Revenue generated (in %) of Ukraine in 2008 to that in 2009?
Provide a short and direct response. 1.36. What is the difference between the highest and the second highest Revenue generated (in %) in Burkina Faso?
Provide a short and direct response. 0.41. What is the difference between the highest and the second highest Revenue generated (in %) of Congo (Democratic)?
Your answer should be very brief. 3.28. What is the difference between the highest and the second highest Revenue generated (in %) of Netherlands?
Provide a short and direct response. 0.72. What is the difference between the highest and the second highest Revenue generated (in %) in Ukraine?
Offer a terse response. 0.44. What is the difference between the highest and the lowest Revenue generated (in %) in Burkina Faso?
Keep it short and to the point. 2.58. What is the difference between the highest and the lowest Revenue generated (in %) of Congo (Democratic)?
Ensure brevity in your answer.  9.07. What is the difference between the highest and the lowest Revenue generated (in %) in Netherlands?
Your response must be concise. 3.03. What is the difference between the highest and the lowest Revenue generated (in %) in Ukraine?
Make the answer very short. 5.82. 